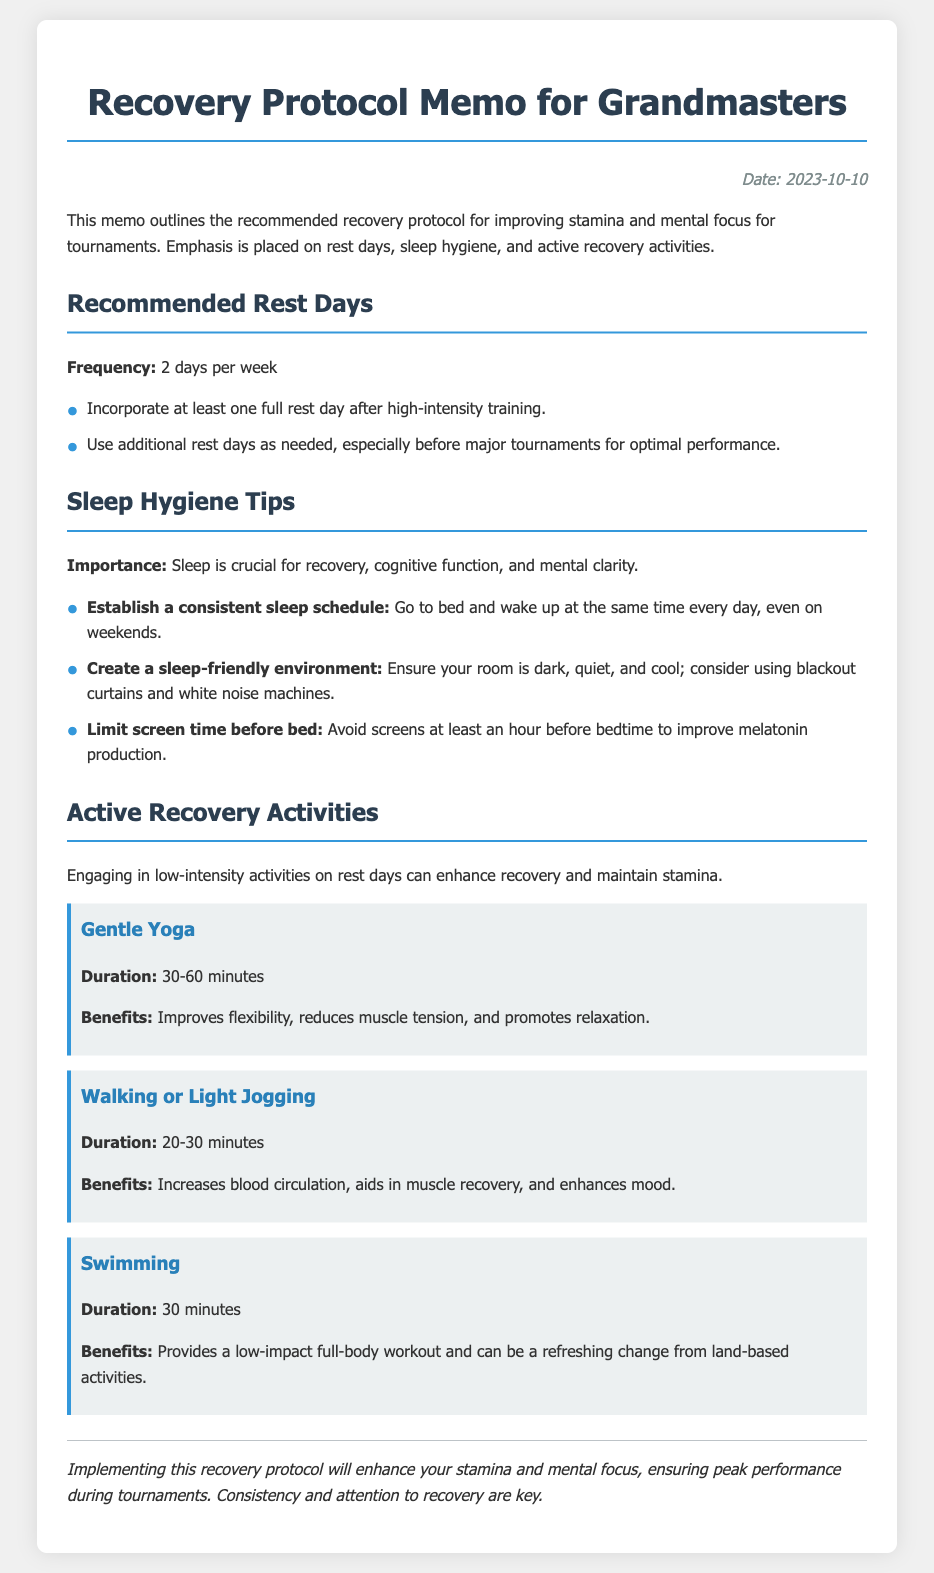What is the date of the memo? The date of the memo is specified in the document header.
Answer: 2023-10-10 How many rest days are recommended per week? The document mentions the frequency of rest days clearly in the section about recommended rest days.
Answer: 2 days What should be done after high-intensity training? The memo outlines a specific practice for optimal recovery following high-intensity training.
Answer: Full rest day What is the suggested duration for gentle yoga? The document specifies the duration for the active recovery activity of gentle yoga.
Answer: 30-60 minutes What activity can increase blood circulation on rest days? The document lists walking or light jogging as an effective active recovery activity.
Answer: Walking or Light Jogging Why is sleep considered crucial according to the memo? The importance of sleep is highlighted regarding recovery and cognitive processes as stated in the relevant section.
Answer: Recovery, cognitive function, and mental clarity What does the memo suggest about screen time before bed? The document gives specific advice on managing screen time to aid in better sleep hygiene.
Answer: Limit screen time before bed What type of environment should be created for better sleep? The memo discusses specific environmental factors that contribute to a sleep-friendly atmosphere.
Answer: Dark, quiet, and cool What is one benefit of swimming mentioned in the document? The memo outlines a specific advantage of incorporating swimming into active recovery routines.
Answer: Low-impact full-body workout 